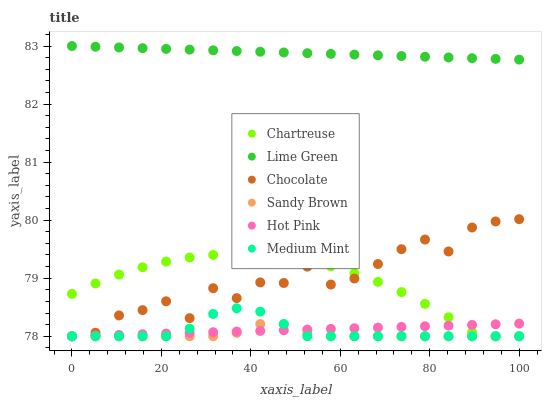Does Sandy Brown have the minimum area under the curve?
Answer yes or no. Yes. Does Lime Green have the maximum area under the curve?
Answer yes or no. Yes. Does Hot Pink have the minimum area under the curve?
Answer yes or no. No. Does Hot Pink have the maximum area under the curve?
Answer yes or no. No. Is Lime Green the smoothest?
Answer yes or no. Yes. Is Chocolate the roughest?
Answer yes or no. Yes. Is Hot Pink the smoothest?
Answer yes or no. No. Is Hot Pink the roughest?
Answer yes or no. No. Does Medium Mint have the lowest value?
Answer yes or no. Yes. Does Lime Green have the lowest value?
Answer yes or no. No. Does Lime Green have the highest value?
Answer yes or no. Yes. Does Hot Pink have the highest value?
Answer yes or no. No. Is Chartreuse less than Lime Green?
Answer yes or no. Yes. Is Lime Green greater than Chartreuse?
Answer yes or no. Yes. Does Sandy Brown intersect Chocolate?
Answer yes or no. Yes. Is Sandy Brown less than Chocolate?
Answer yes or no. No. Is Sandy Brown greater than Chocolate?
Answer yes or no. No. Does Chartreuse intersect Lime Green?
Answer yes or no. No. 